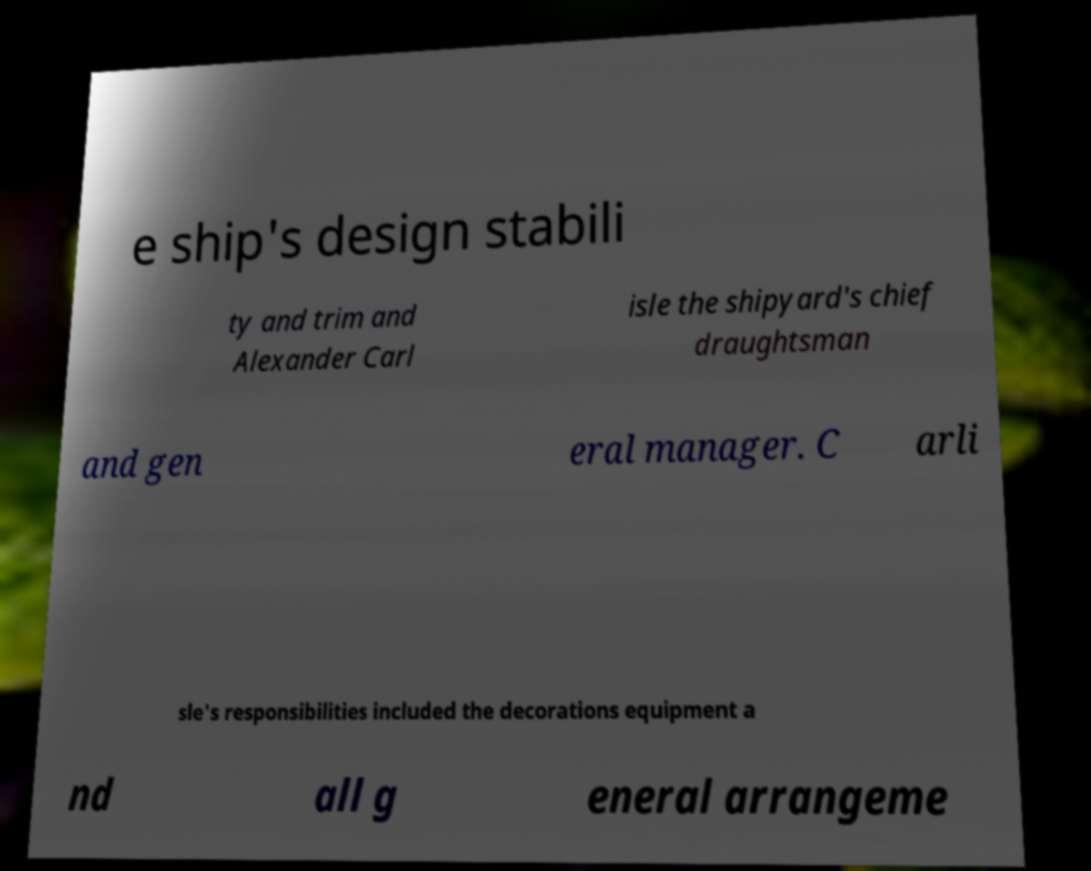Can you accurately transcribe the text from the provided image for me? e ship's design stabili ty and trim and Alexander Carl isle the shipyard's chief draughtsman and gen eral manager. C arli sle's responsibilities included the decorations equipment a nd all g eneral arrangeme 